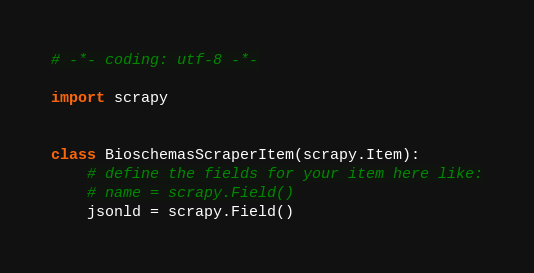<code> <loc_0><loc_0><loc_500><loc_500><_Python_># -*- coding: utf-8 -*-

import scrapy


class BioschemasScraperItem(scrapy.Item):
    # define the fields for your item here like:
    # name = scrapy.Field()
    jsonld = scrapy.Field()
</code> 